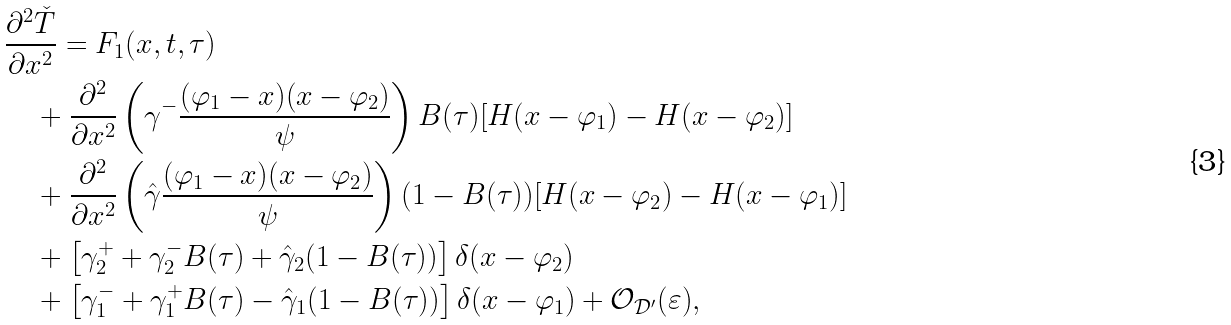<formula> <loc_0><loc_0><loc_500><loc_500>& \frac { \partial ^ { 2 } \check { T } } { \partial x ^ { 2 } } = F _ { 1 } ( x , t , \tau ) \\ & \quad + \frac { \partial ^ { 2 } } { \partial x ^ { 2 } } \left ( \gamma ^ { - } \frac { ( \varphi _ { 1 } - x ) ( x - \varphi _ { 2 } ) } { \psi } \right ) B ( \tau ) [ H ( x - \varphi _ { 1 } ) - H ( x - \varphi _ { 2 } ) ] \\ & \quad + \frac { \partial ^ { 2 } } { \partial x ^ { 2 } } \left ( \hat { \gamma } \frac { ( \varphi _ { 1 } - x ) ( x - \varphi _ { 2 } ) } { \psi } \right ) ( 1 - B ( \tau ) ) [ H ( x - \varphi _ { 2 } ) - H ( x - \varphi _ { 1 } ) ] \\ & \quad + \left [ \gamma _ { 2 } ^ { + } + \gamma _ { 2 } ^ { - } B ( \tau ) + \hat { \gamma } _ { 2 } ( 1 - B ( \tau ) ) \right ] \delta ( x - \varphi _ { 2 } ) \\ & \quad + \left [ \gamma _ { 1 } ^ { - } + \gamma _ { 1 } ^ { + } B ( \tau ) - \hat { \gamma } _ { 1 } ( 1 - B ( \tau ) ) \right ] \delta ( x - \varphi _ { 1 } ) + \mathcal { O } _ { \mathcal { D } ^ { \prime } } ( \varepsilon ) ,</formula> 